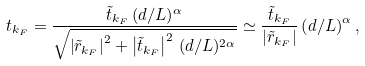Convert formula to latex. <formula><loc_0><loc_0><loc_500><loc_500>t _ { k _ { F } } = \frac { \tilde { t } _ { k _ { F } } \, ( d / L ) ^ { \alpha } } { \sqrt { \left | \tilde { r } _ { k _ { F } } \right | ^ { 2 } + \left | \tilde { t } _ { k _ { F } } \right | ^ { 2 } \, ( d / L ) ^ { 2 \alpha } } } \simeq \frac { \tilde { t } _ { k _ { F } } } { | \tilde { r } _ { k _ { F } } | } \left ( d / L \right ) ^ { \alpha } ,</formula> 